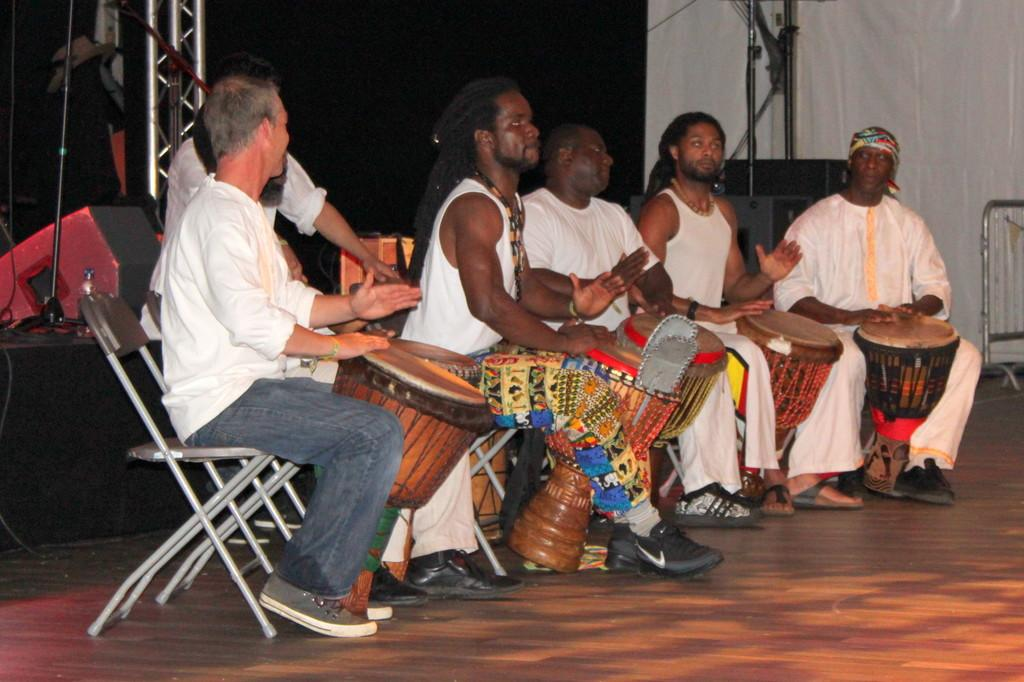Who is present in the image? There are men in the image. What are the men doing in the image? The men are sitting on chairs and playing tabla. What is the floor made of in the image? The floor is made of wood. Can you describe the setting where the men are playing tabla? There is a stage visible in the image. What type of operation is being performed on the channel in the image? There is no operation or channel present in the image; it features men playing tabla on a stage with a wooden floor. 